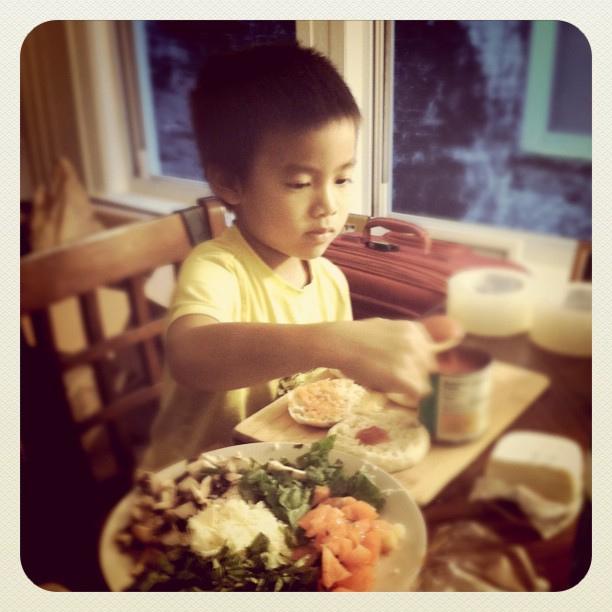How many different kinds of food are on the plate to the boy's right?
Write a very short answer. 5. How many hands are holding the sandwiches?
Short answer required. 1. Is the boy Caucasian?
Be succinct. No. What's on the plate?
Short answer required. Dinner. What is the child sitting in?
Quick response, please. Chair. What food is shown?
Write a very short answer. Salad. What is the boy doing?
Give a very brief answer. Eating. 